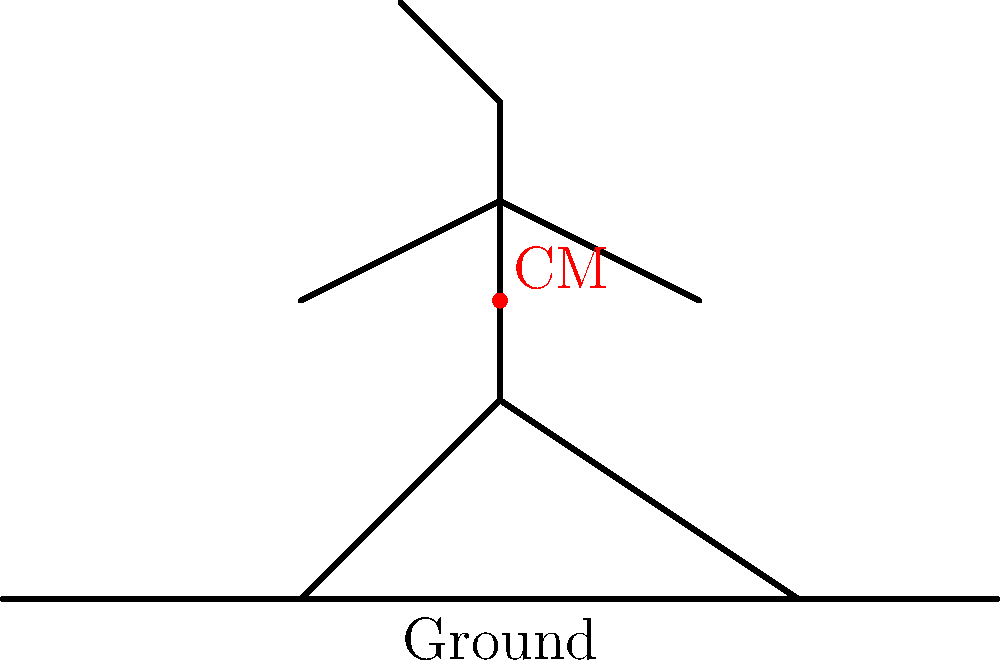During a sliding tackle, a football player extends one leg forward while lowering their body closer to the ground. Consider the stick figure representation above. How does this change in body position affect the player's center of mass (CM) and overall stability? To understand the effect of the sliding tackle on the player's center of mass and stability, let's analyze the biomechanics step by step:

1. Initial position: In a standing position, a player's center of mass is typically located near the center of their torso.

2. Sliding tackle motion:
   a. The player extends one leg forward
   b. They lower their body closer to the ground

3. Effect on center of mass:
   a. Vertical shift: The CM moves downward as the body lowers
   b. Horizontal shift: The CM moves slightly forward due to the extended leg

4. Changes in stability:
   a. Lower center of mass: Increases stability by reducing the height of the CM above the ground
   b. Increased base of support: The extended leg creates a larger area of contact with the ground

5. Biomechanical advantages:
   a. Increased stability: Lower CM and larger base of support make the player less likely to be knocked off balance
   b. Improved momentum: The forward shift of the CM helps generate forward motion for the tackle

6. Relationship to football history:
   This biomechanical understanding has led to the refinement of sliding tackle techniques over time, contributing to the evolution of defensive strategies in football.

In summary, during a sliding tackle, the player's center of mass lowers and shifts slightly forward, resulting in increased stability and improved tackle effectiveness.
Answer: Lowered and slightly forward-shifted CM, increasing stability and tackle effectiveness. 